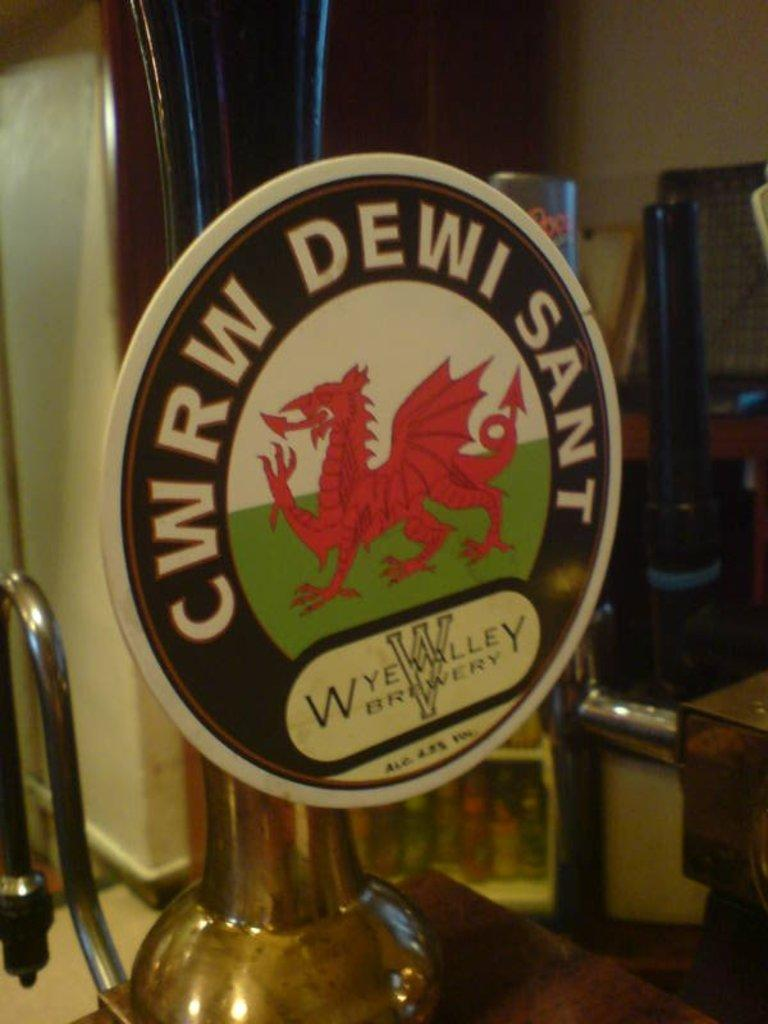<image>
Create a compact narrative representing the image presented. Beer tap for CWRW Dewi Sant" showing an image of a red dragon. 